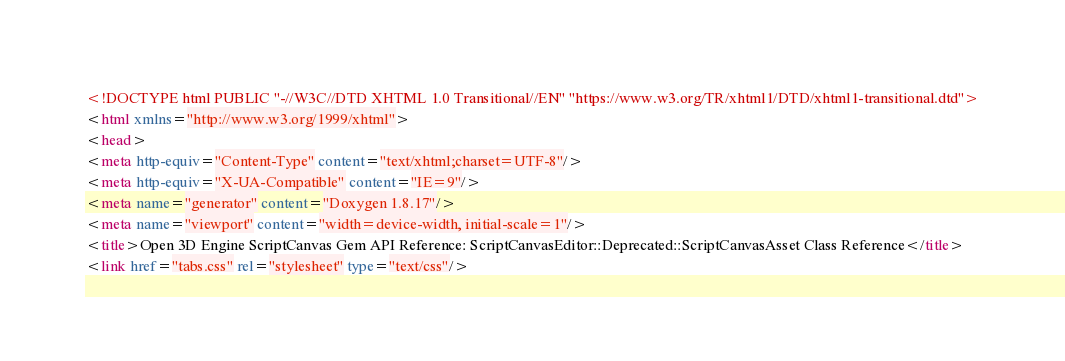Convert code to text. <code><loc_0><loc_0><loc_500><loc_500><_HTML_><!DOCTYPE html PUBLIC "-//W3C//DTD XHTML 1.0 Transitional//EN" "https://www.w3.org/TR/xhtml1/DTD/xhtml1-transitional.dtd">
<html xmlns="http://www.w3.org/1999/xhtml">
<head>
<meta http-equiv="Content-Type" content="text/xhtml;charset=UTF-8"/>
<meta http-equiv="X-UA-Compatible" content="IE=9"/>
<meta name="generator" content="Doxygen 1.8.17"/>
<meta name="viewport" content="width=device-width, initial-scale=1"/>
<title>Open 3D Engine ScriptCanvas Gem API Reference: ScriptCanvasEditor::Deprecated::ScriptCanvasAsset Class Reference</title>
<link href="tabs.css" rel="stylesheet" type="text/css"/></code> 